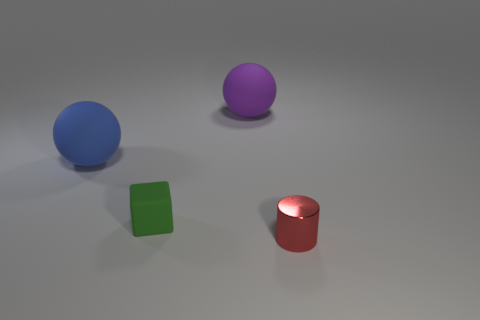Add 4 big purple balls. How many objects exist? 8 Subtract all cylinders. How many objects are left? 3 Add 1 tiny blocks. How many tiny blocks exist? 2 Subtract all blue balls. How many balls are left? 1 Subtract 0 purple blocks. How many objects are left? 4 Subtract 2 balls. How many balls are left? 0 Subtract all blue balls. Subtract all yellow cylinders. How many balls are left? 1 Subtract all green matte objects. Subtract all small rubber objects. How many objects are left? 2 Add 3 red shiny cylinders. How many red shiny cylinders are left? 4 